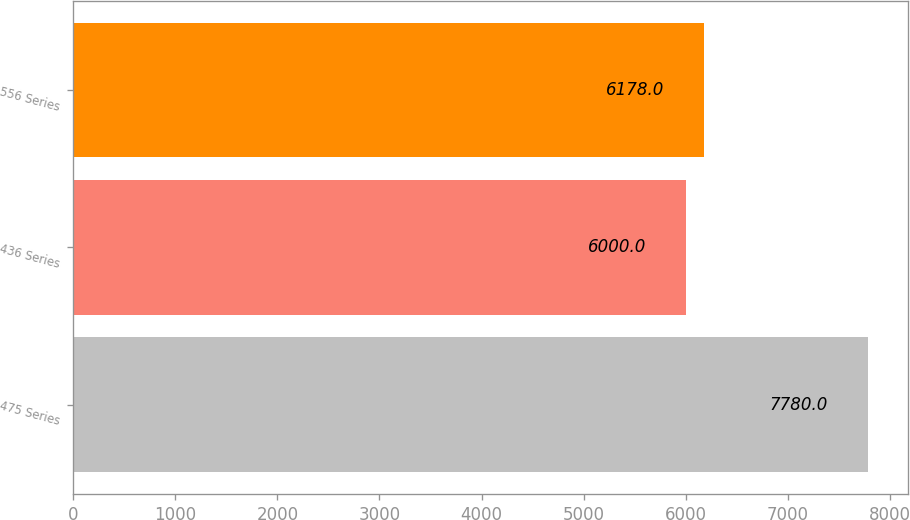Convert chart. <chart><loc_0><loc_0><loc_500><loc_500><bar_chart><fcel>475 Series<fcel>436 Series<fcel>556 Series<nl><fcel>7780<fcel>6000<fcel>6178<nl></chart> 